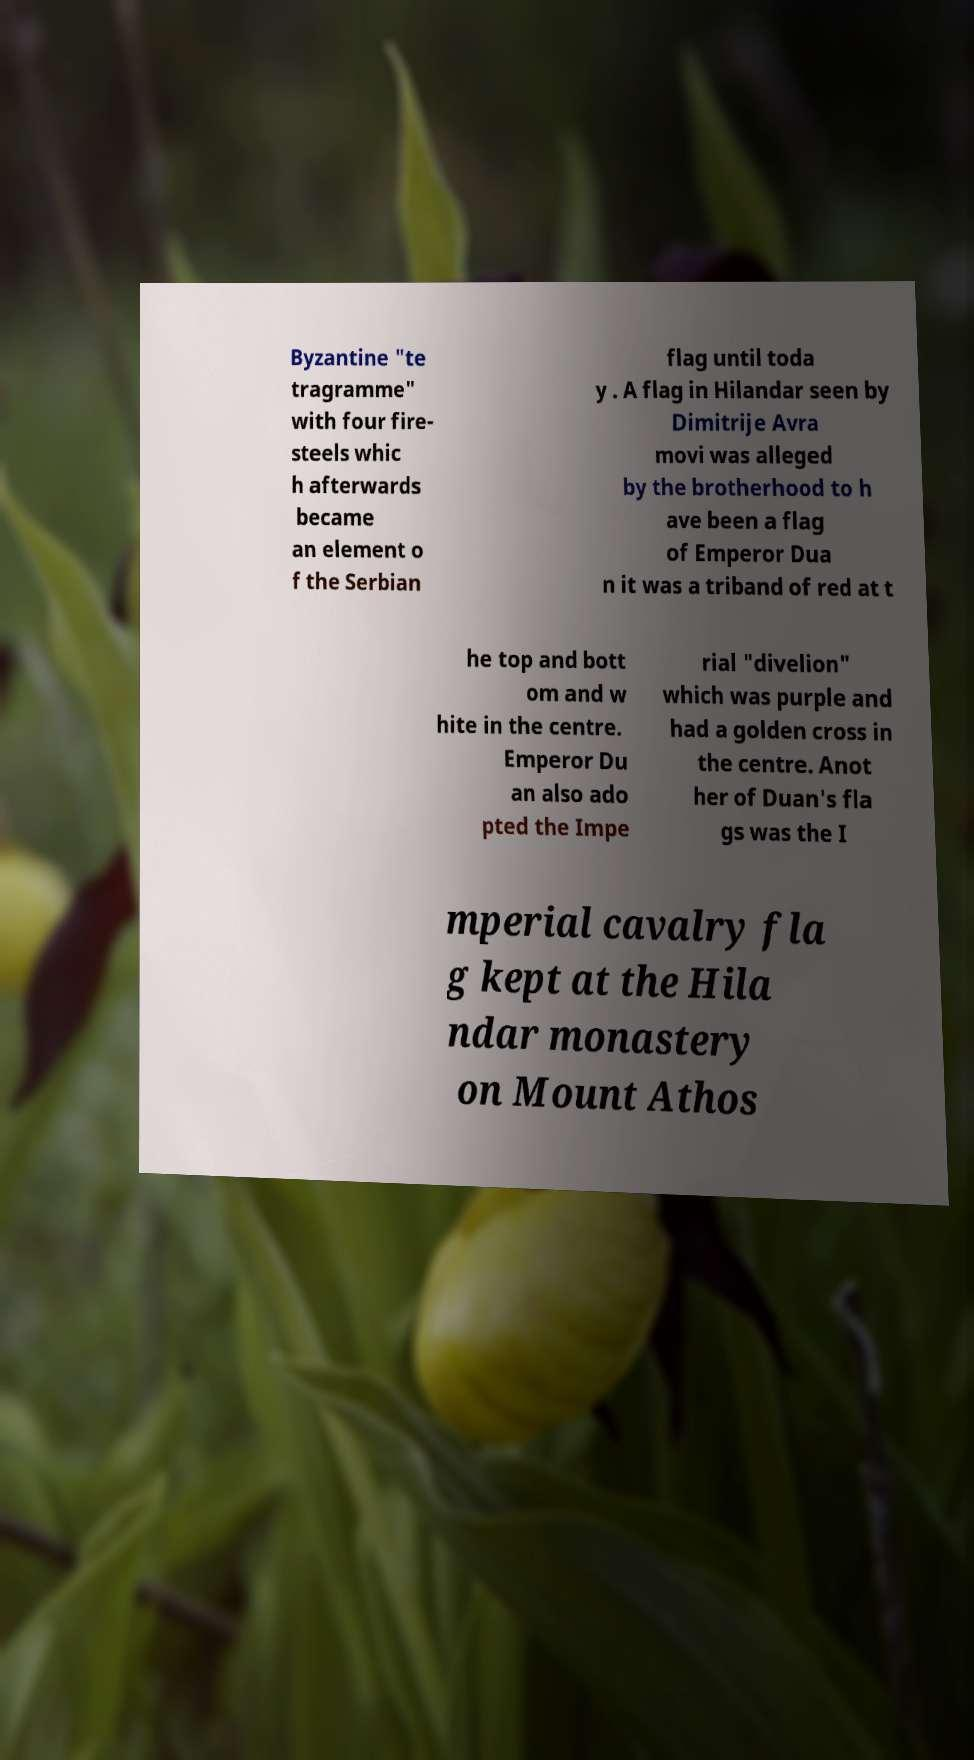Could you assist in decoding the text presented in this image and type it out clearly? Byzantine "te tragramme" with four fire- steels whic h afterwards became an element o f the Serbian flag until toda y . A flag in Hilandar seen by Dimitrije Avra movi was alleged by the brotherhood to h ave been a flag of Emperor Dua n it was a triband of red at t he top and bott om and w hite in the centre. Emperor Du an also ado pted the Impe rial "divelion" which was purple and had a golden cross in the centre. Anot her of Duan's fla gs was the I mperial cavalry fla g kept at the Hila ndar monastery on Mount Athos 